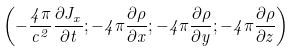<formula> <loc_0><loc_0><loc_500><loc_500>\left ( - \frac { 4 \pi } { c ^ { 2 } } \frac { \partial J _ { x } } { \partial t } ; - 4 \pi \frac { \partial \rho } { \partial x } ; - 4 \pi \frac { \partial \rho } { \partial y } ; - 4 \pi \frac { \partial \rho } { \partial z } \right )</formula> 